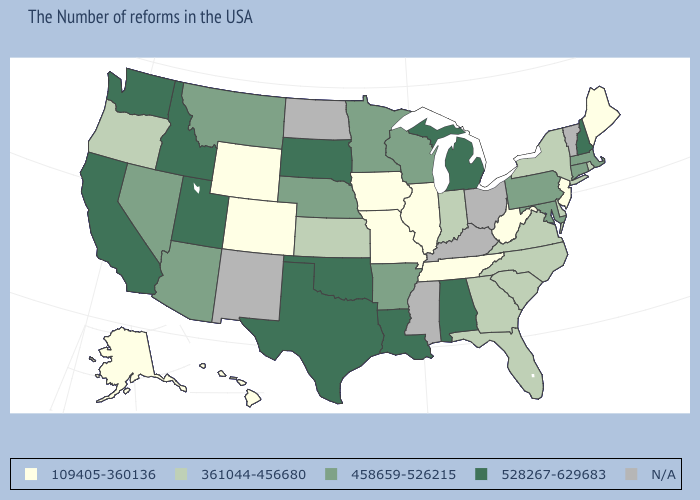Does the map have missing data?
Be succinct. Yes. How many symbols are there in the legend?
Give a very brief answer. 5. What is the value of Tennessee?
Write a very short answer. 109405-360136. Name the states that have a value in the range 528267-629683?
Quick response, please. New Hampshire, Michigan, Alabama, Louisiana, Oklahoma, Texas, South Dakota, Utah, Idaho, California, Washington. What is the value of Iowa?
Write a very short answer. 109405-360136. What is the value of Minnesota?
Quick response, please. 458659-526215. Name the states that have a value in the range 361044-456680?
Short answer required. Rhode Island, New York, Delaware, Virginia, North Carolina, South Carolina, Florida, Georgia, Indiana, Kansas, Oregon. What is the highest value in the USA?
Answer briefly. 528267-629683. Which states have the lowest value in the Northeast?
Be succinct. Maine, New Jersey. Is the legend a continuous bar?
Be succinct. No. Among the states that border Utah , does Nevada have the lowest value?
Give a very brief answer. No. Which states have the lowest value in the USA?
Answer briefly. Maine, New Jersey, West Virginia, Tennessee, Illinois, Missouri, Iowa, Wyoming, Colorado, Alaska, Hawaii. Which states hav the highest value in the Northeast?
Short answer required. New Hampshire. 